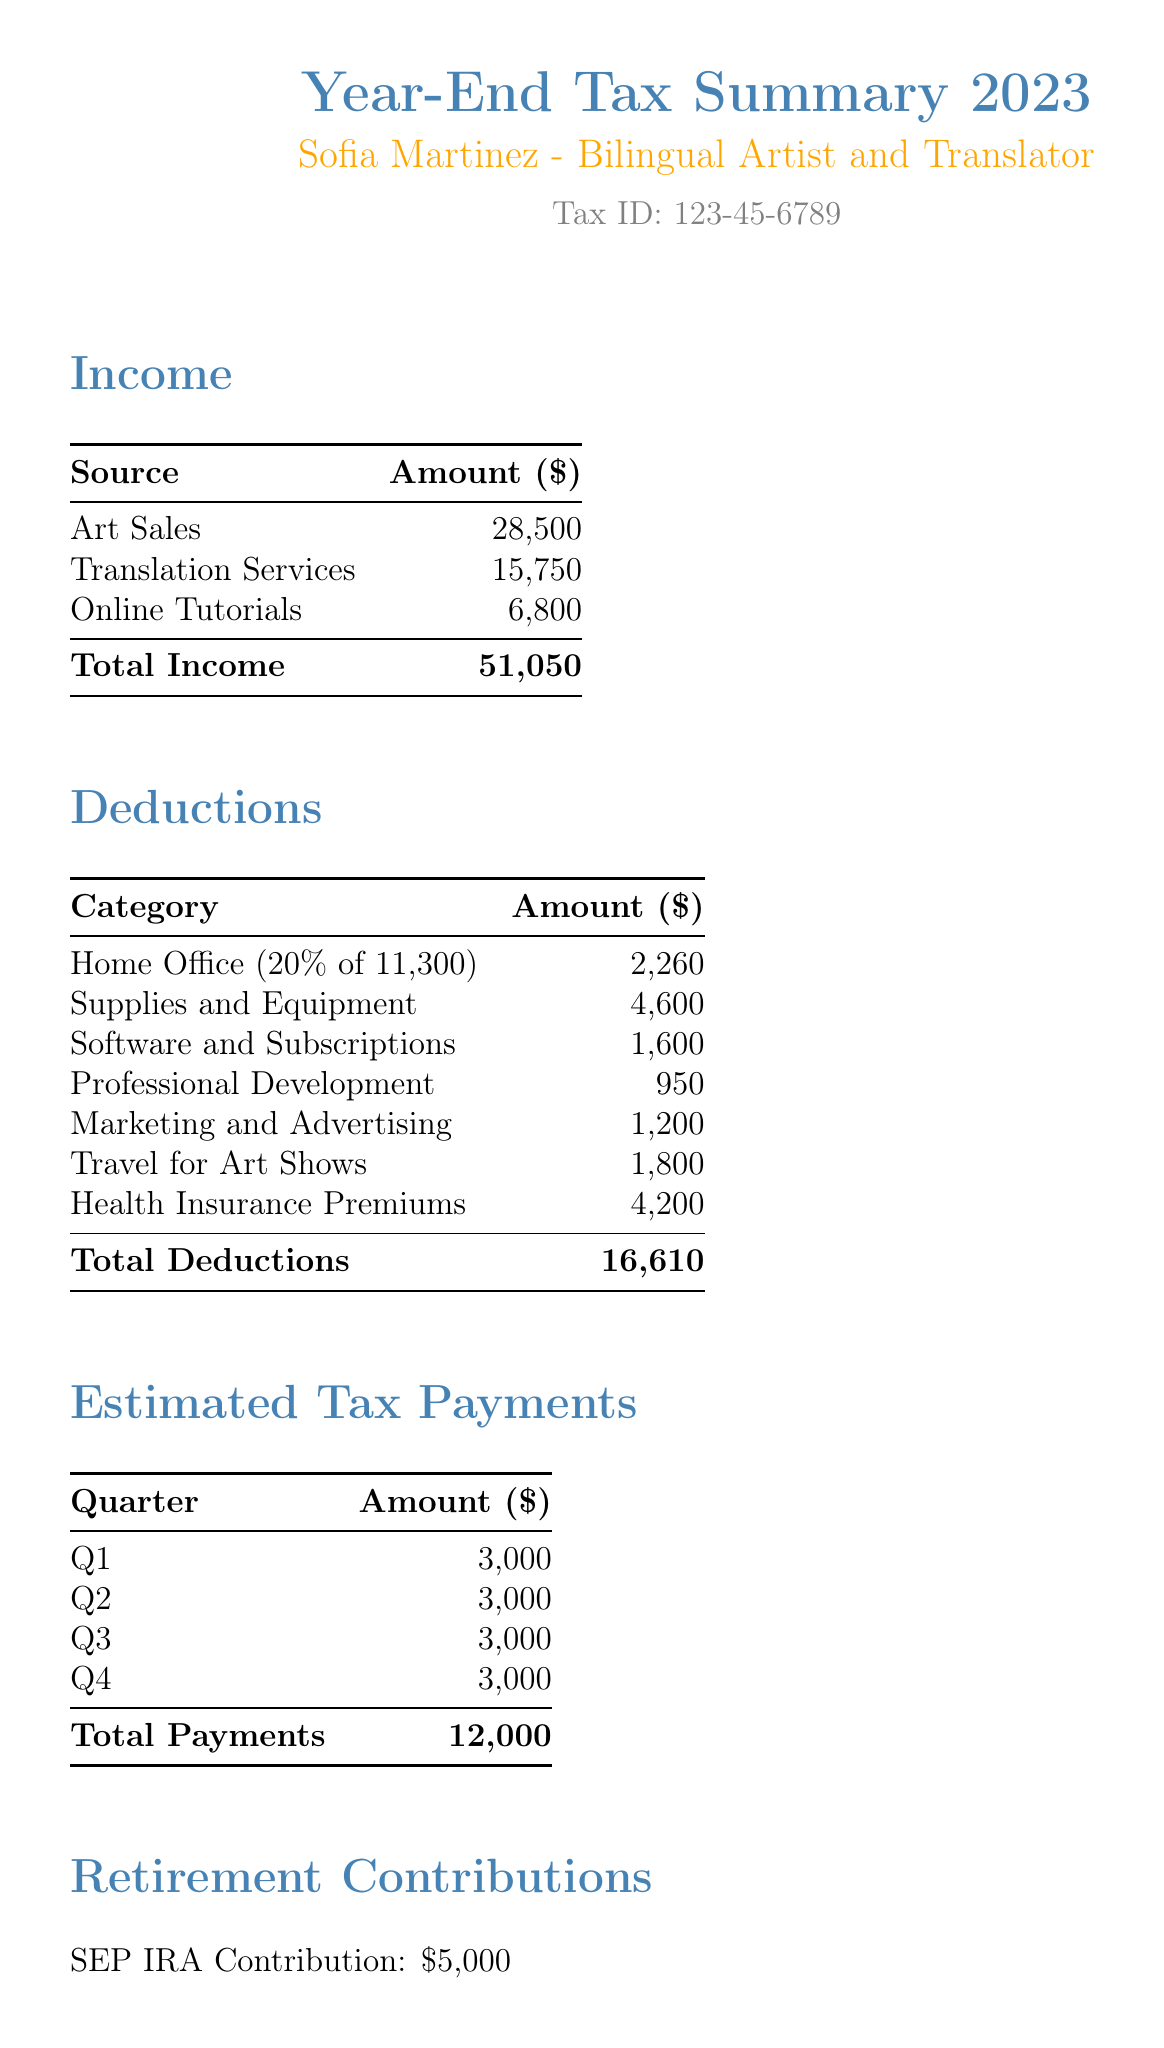what is the total income? The total income is the sum of all income sources listed in the document, which is 28500 + 15750 + 6800.
Answer: 51050 how much was spent on marketing and advertising? The document lists 1200 as the amount spent on marketing and advertising.
Answer: 1200 what is the amount for health insurance premiums? The health insurance premiums amount is specified as 4200 in the deductions section.
Answer: 4200 how much did Sofia contribute to her retirement? The document states that the SEP IRA contribution was 5000.
Answer: 5000 what percentage of the home is used for the home office? The document indicates that the home office deduction is calculated based on 20% of the total home square footage.
Answer: 20% what is the total amount of deductions? The total deductions are provided at the end of the deductions section, amounting to 16610.
Answer: 16610 how many estimated tax payments were made in total? The total payments for the year, as noted, amount to 12000.
Answer: 12000 which software had the highest subscription cost? The SDL Trados translation software is listed as costing 850, the highest among the software and subscriptions.
Answer: SDL Trados translation software what was the income from online tutorials? The document states that the income from online tutorials is 6800.
Answer: 6800 